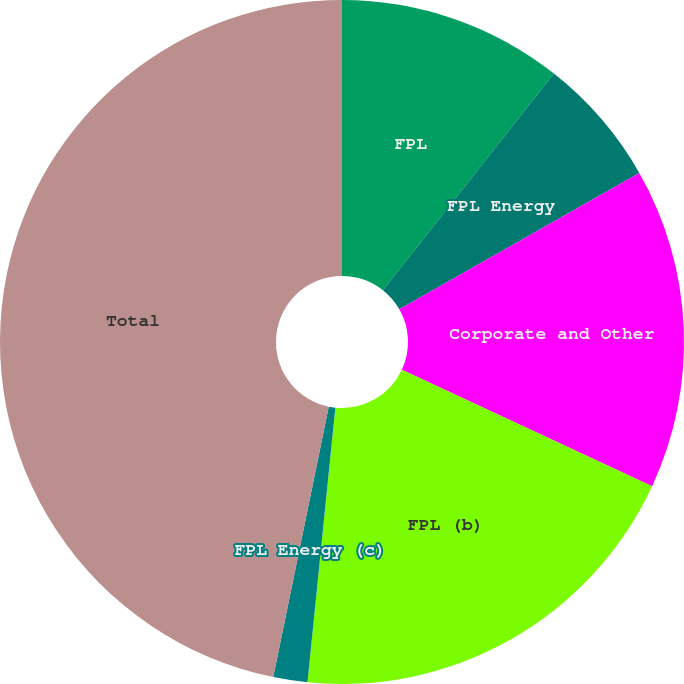Convert chart to OTSL. <chart><loc_0><loc_0><loc_500><loc_500><pie_chart><fcel>FPL<fcel>FPL Energy<fcel>Corporate and Other<fcel>FPL (b)<fcel>FPL Energy (c)<fcel>Total<nl><fcel>10.64%<fcel>6.13%<fcel>15.16%<fcel>19.68%<fcel>1.61%<fcel>46.78%<nl></chart> 